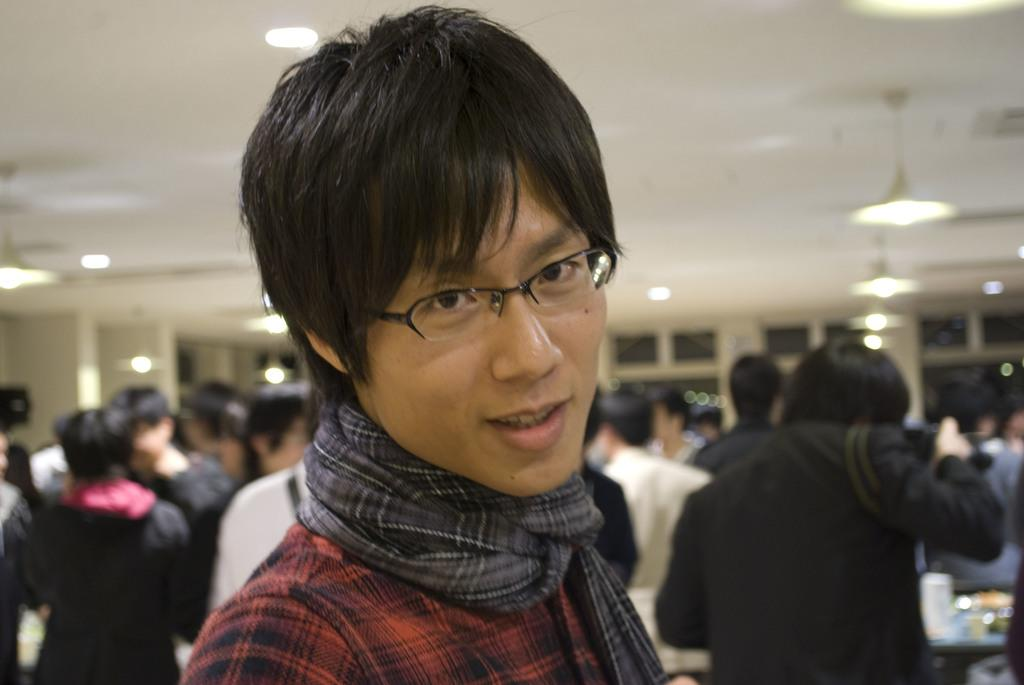Who is the main subject in the image? There is a man in the center of the image. Are there any other people visible in the image? Yes, there are other people behind the man. What can be seen in the background of the image? There are lamps and windows in the background of the image. What is the opinion of the birds in the image? There are no birds present in the image, so it is not possible to determine their opinion. 